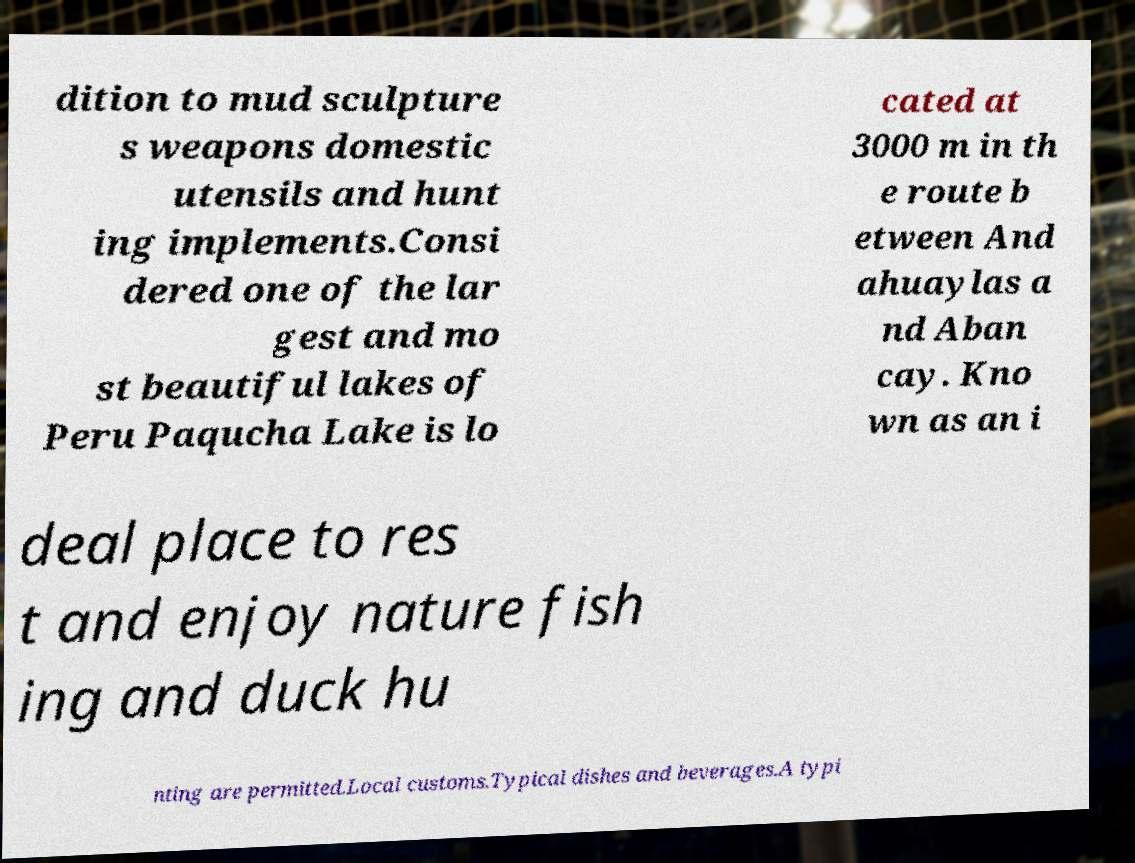What messages or text are displayed in this image? I need them in a readable, typed format. dition to mud sculpture s weapons domestic utensils and hunt ing implements.Consi dered one of the lar gest and mo st beautiful lakes of Peru Paqucha Lake is lo cated at 3000 m in th e route b etween And ahuaylas a nd Aban cay. Kno wn as an i deal place to res t and enjoy nature fish ing and duck hu nting are permitted.Local customs.Typical dishes and beverages.A typi 